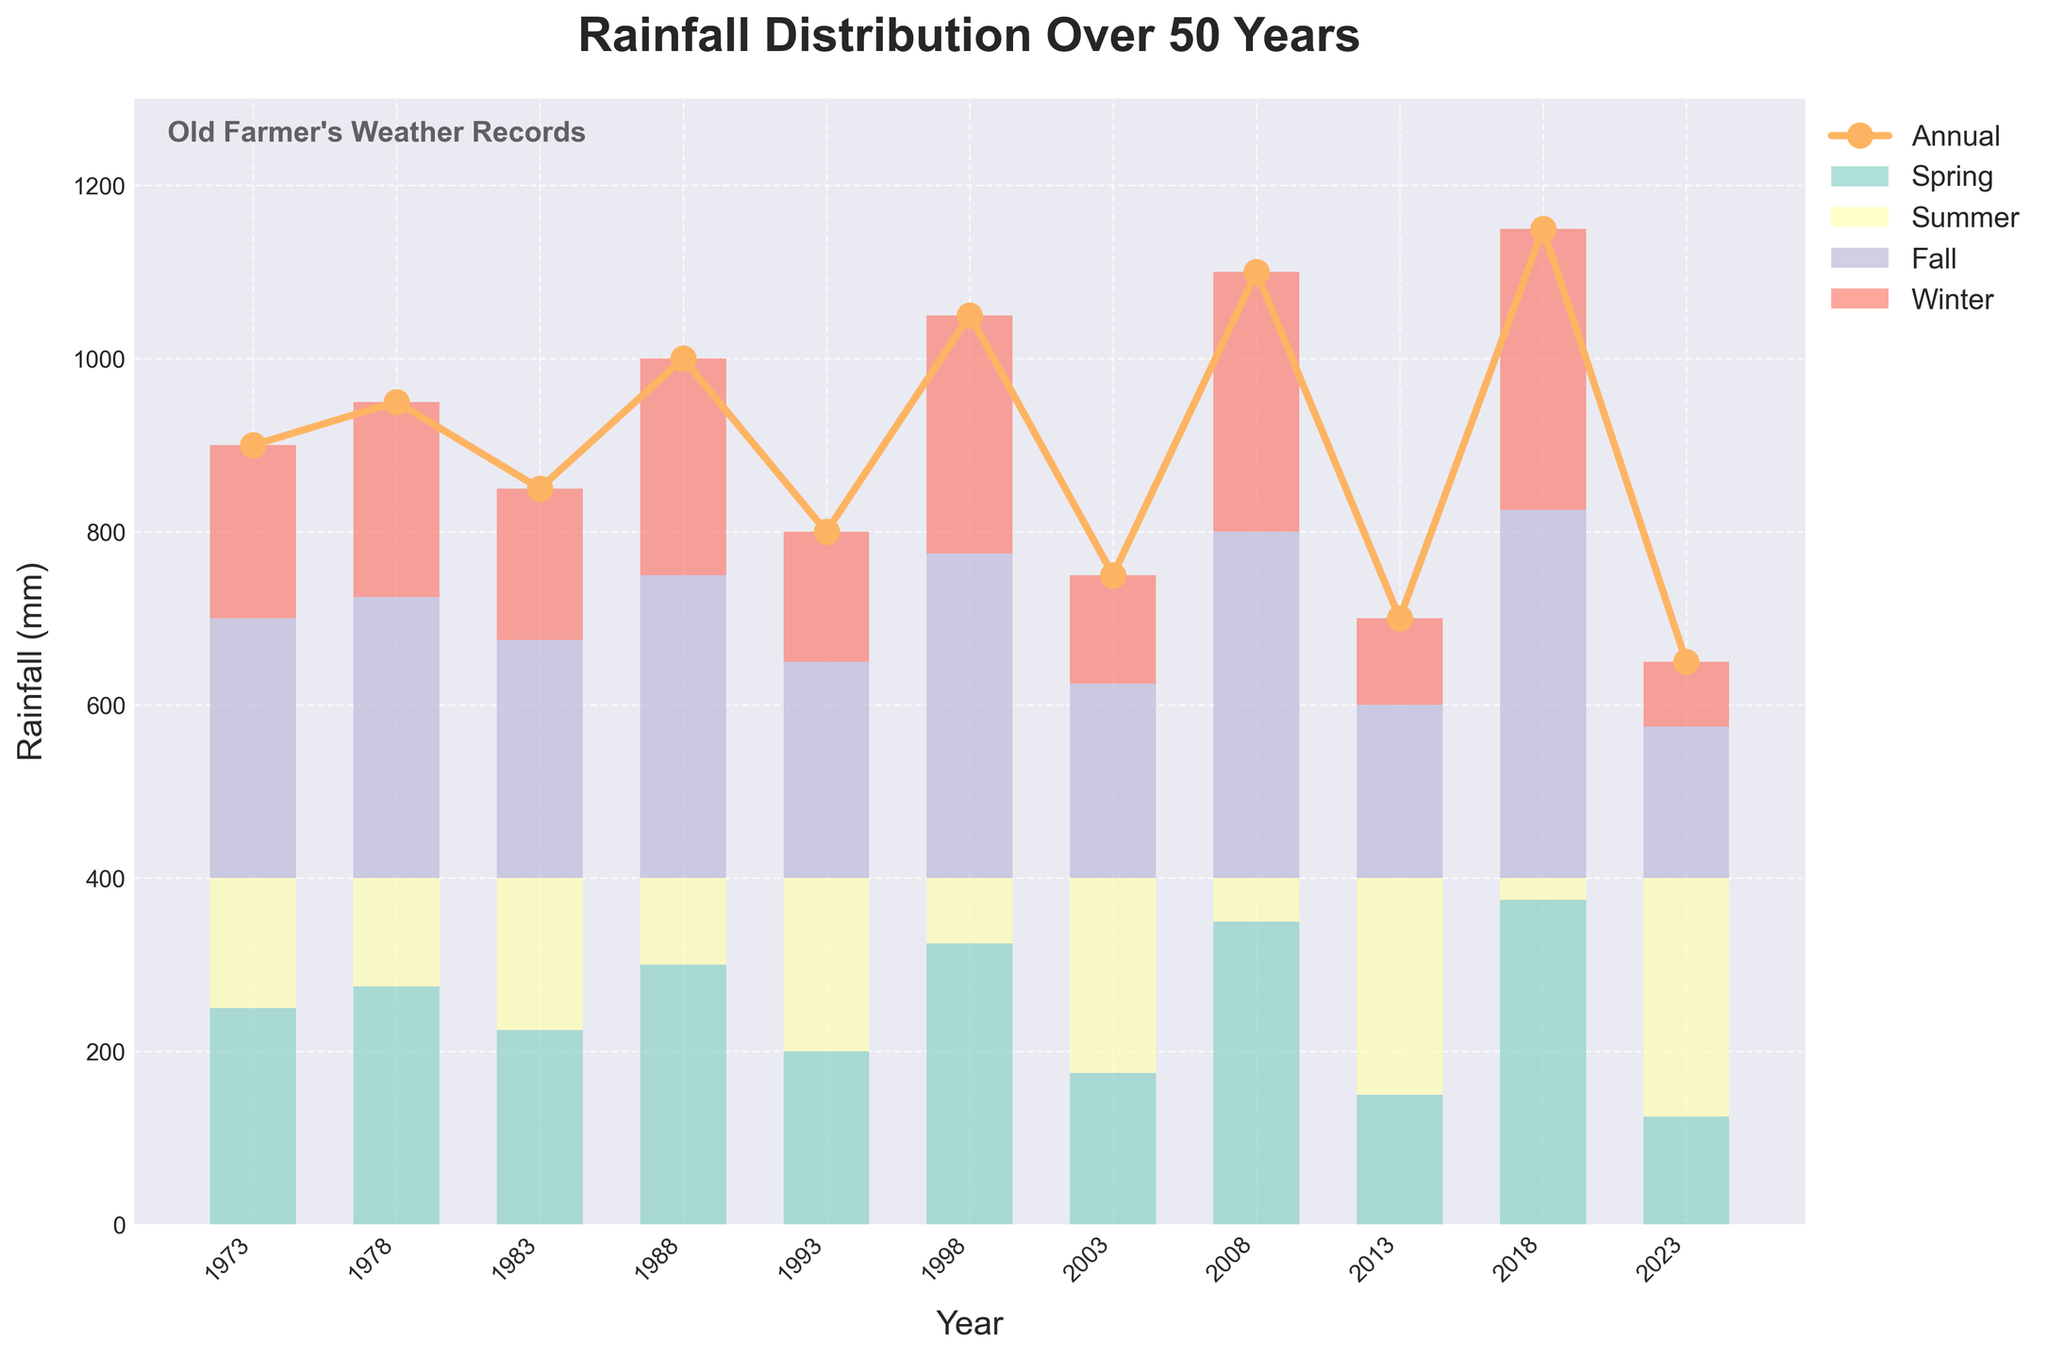How many years of data are represented in the chart? Count the number of years displayed on the x-axis.
Answer: 11 What is the title of the chart? Look at the title at the top of the chart.
Answer: "Rainfall Distribution Over 50 Years" In which year did the annual rainfall peak? Find the year corresponding to the highest point on the Annual line plot.
Answer: 2018 Which season had the highest rainfall in 1998? Identify the highest bar segment for the year 1998.
Answer: Fall By how much did the annual rainfall decrease from 2008 to 2013? Subtract the annual rainfall of 2013 from that of 2008.
Answer: 400 mm What is the average seasonal rainfall in 2023? Sum the rainfall of all four seasons in 2023 and divide by 4.
Answer: 162.5 mm Which two years had the same annual rainfall? Look for years with the same height of the Annual line plot.
Answer: 2003, 2023 By how much did spring rainfall increase from 1993 to 1998? Subtract the spring rainfall of 1993 from that of 1998.
Answer: 125 mm What trend do you observe in the summer rainfall over the years? Observe the pattern of heights for the summer section in the chart for each year.
Answer: Generally increasing Which year had the lowest annual rainfall? Identify the year corresponding to the lowest point on the Annual line plot.
Answer: 2023 